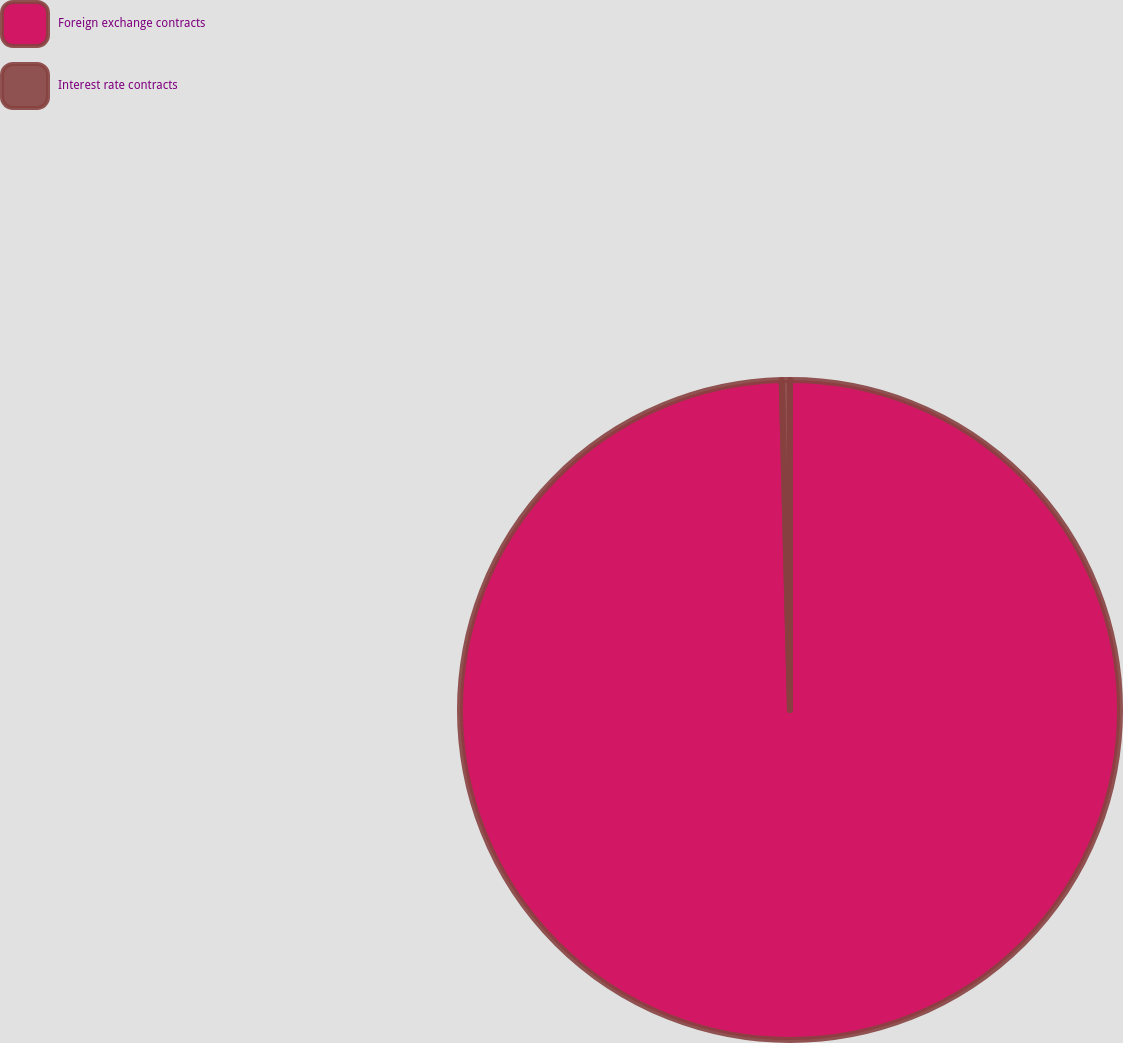Convert chart to OTSL. <chart><loc_0><loc_0><loc_500><loc_500><pie_chart><fcel>Foreign exchange contracts<fcel>Interest rate contracts<nl><fcel>99.6%<fcel>0.4%<nl></chart> 